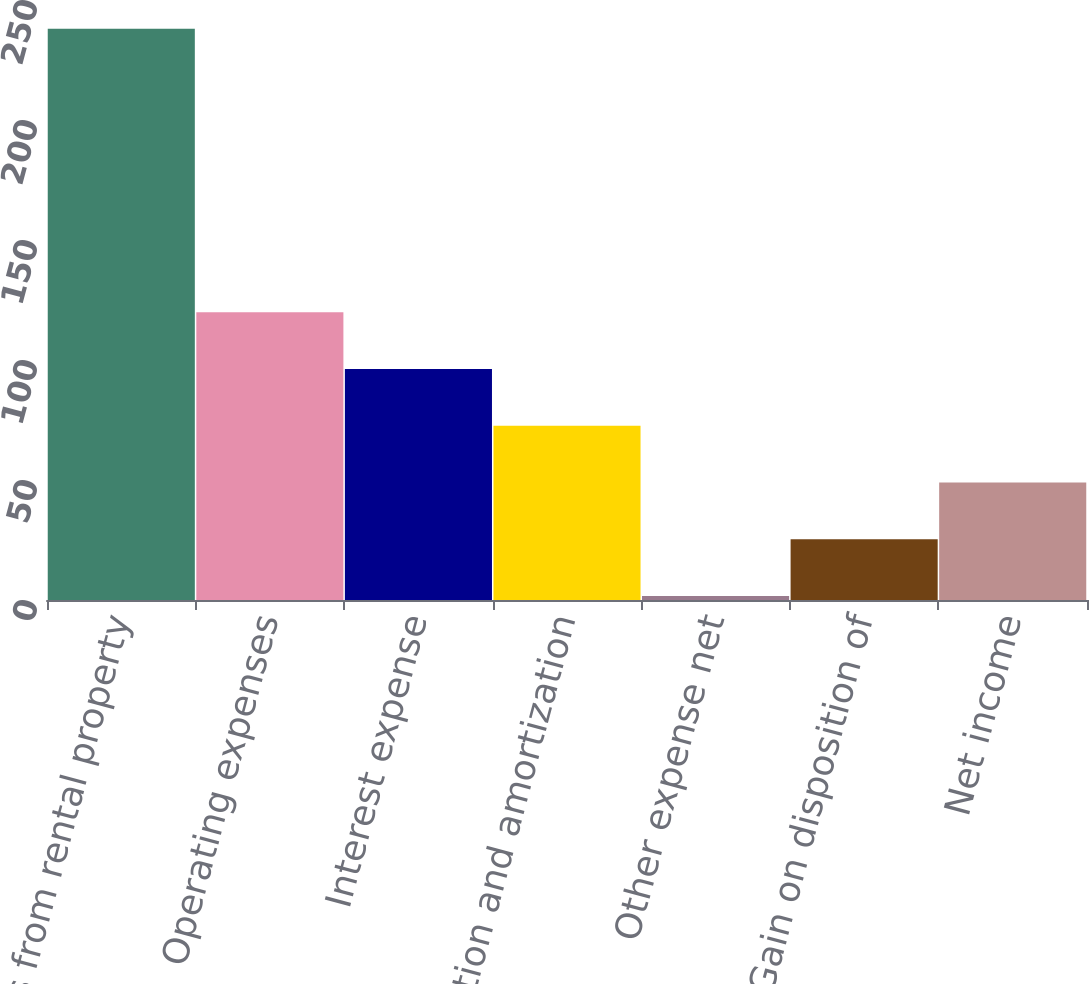Convert chart to OTSL. <chart><loc_0><loc_0><loc_500><loc_500><bar_chart><fcel>Revenues from rental property<fcel>Operating expenses<fcel>Interest expense<fcel>Depreciation and amortization<fcel>Other expense net<fcel>Gain on disposition of<fcel>Net income<nl><fcel>238<fcel>119.85<fcel>96.22<fcel>72.59<fcel>1.7<fcel>25.33<fcel>48.96<nl></chart> 